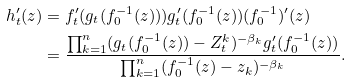<formula> <loc_0><loc_0><loc_500><loc_500>h _ { t } ^ { \prime } ( z ) & = f _ { t } ^ { \prime } ( g _ { t } ( f _ { 0 } ^ { - 1 } ( z ) ) ) g _ { t } ^ { \prime } ( f _ { 0 } ^ { - 1 } ( z ) ) ( f _ { 0 } ^ { - 1 } ) ^ { \prime } ( z ) \\ & = \frac { \prod _ { k = 1 } ^ { n } ( g _ { t } ( f _ { 0 } ^ { - 1 } ( z ) ) - Z ^ { k } _ { t } ) ^ { - \beta _ { k } } g _ { t } ^ { \prime } ( f _ { 0 } ^ { - 1 } ( z ) ) } { \prod _ { k = 1 } ^ { n } ( f _ { 0 } ^ { - 1 } ( z ) - z _ { k } ) ^ { - \beta _ { k } } } .</formula> 